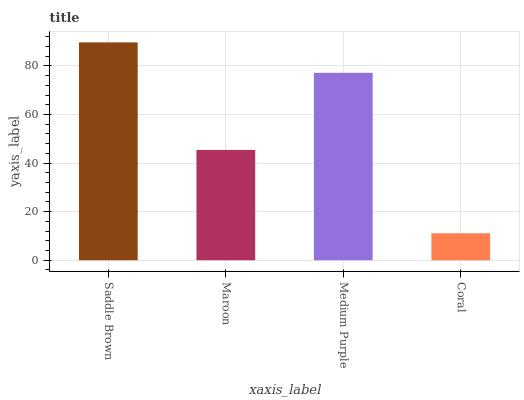Is Coral the minimum?
Answer yes or no. Yes. Is Saddle Brown the maximum?
Answer yes or no. Yes. Is Maroon the minimum?
Answer yes or no. No. Is Maroon the maximum?
Answer yes or no. No. Is Saddle Brown greater than Maroon?
Answer yes or no. Yes. Is Maroon less than Saddle Brown?
Answer yes or no. Yes. Is Maroon greater than Saddle Brown?
Answer yes or no. No. Is Saddle Brown less than Maroon?
Answer yes or no. No. Is Medium Purple the high median?
Answer yes or no. Yes. Is Maroon the low median?
Answer yes or no. Yes. Is Saddle Brown the high median?
Answer yes or no. No. Is Saddle Brown the low median?
Answer yes or no. No. 